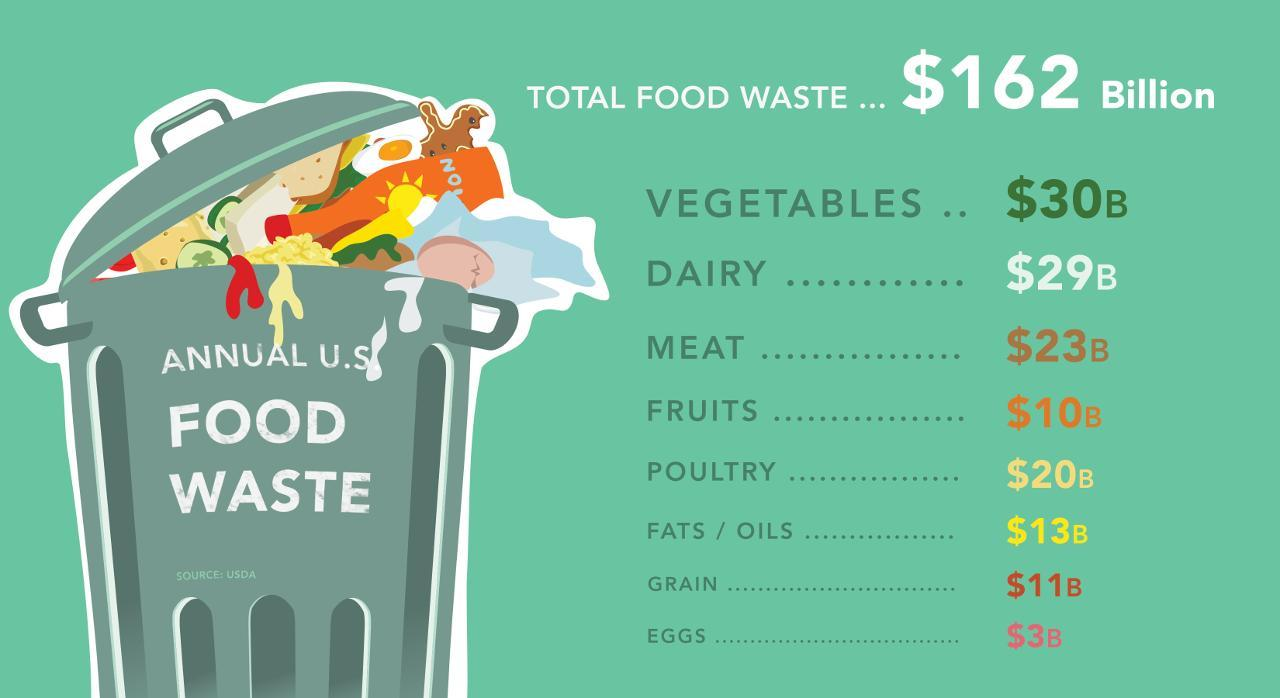What is sum of the food wasted in terms of diary and eggs ?
Answer the question with a short phrase. $ 32B What is total food wasted in terms of Meat and Poultry ? $ 43B What is the sum of food wasted in terms of vegetables and fruits? $ 40B How many items are shown in the list of food wasted? 8 What is written on the trash can? Annual U.S. Food Waste 